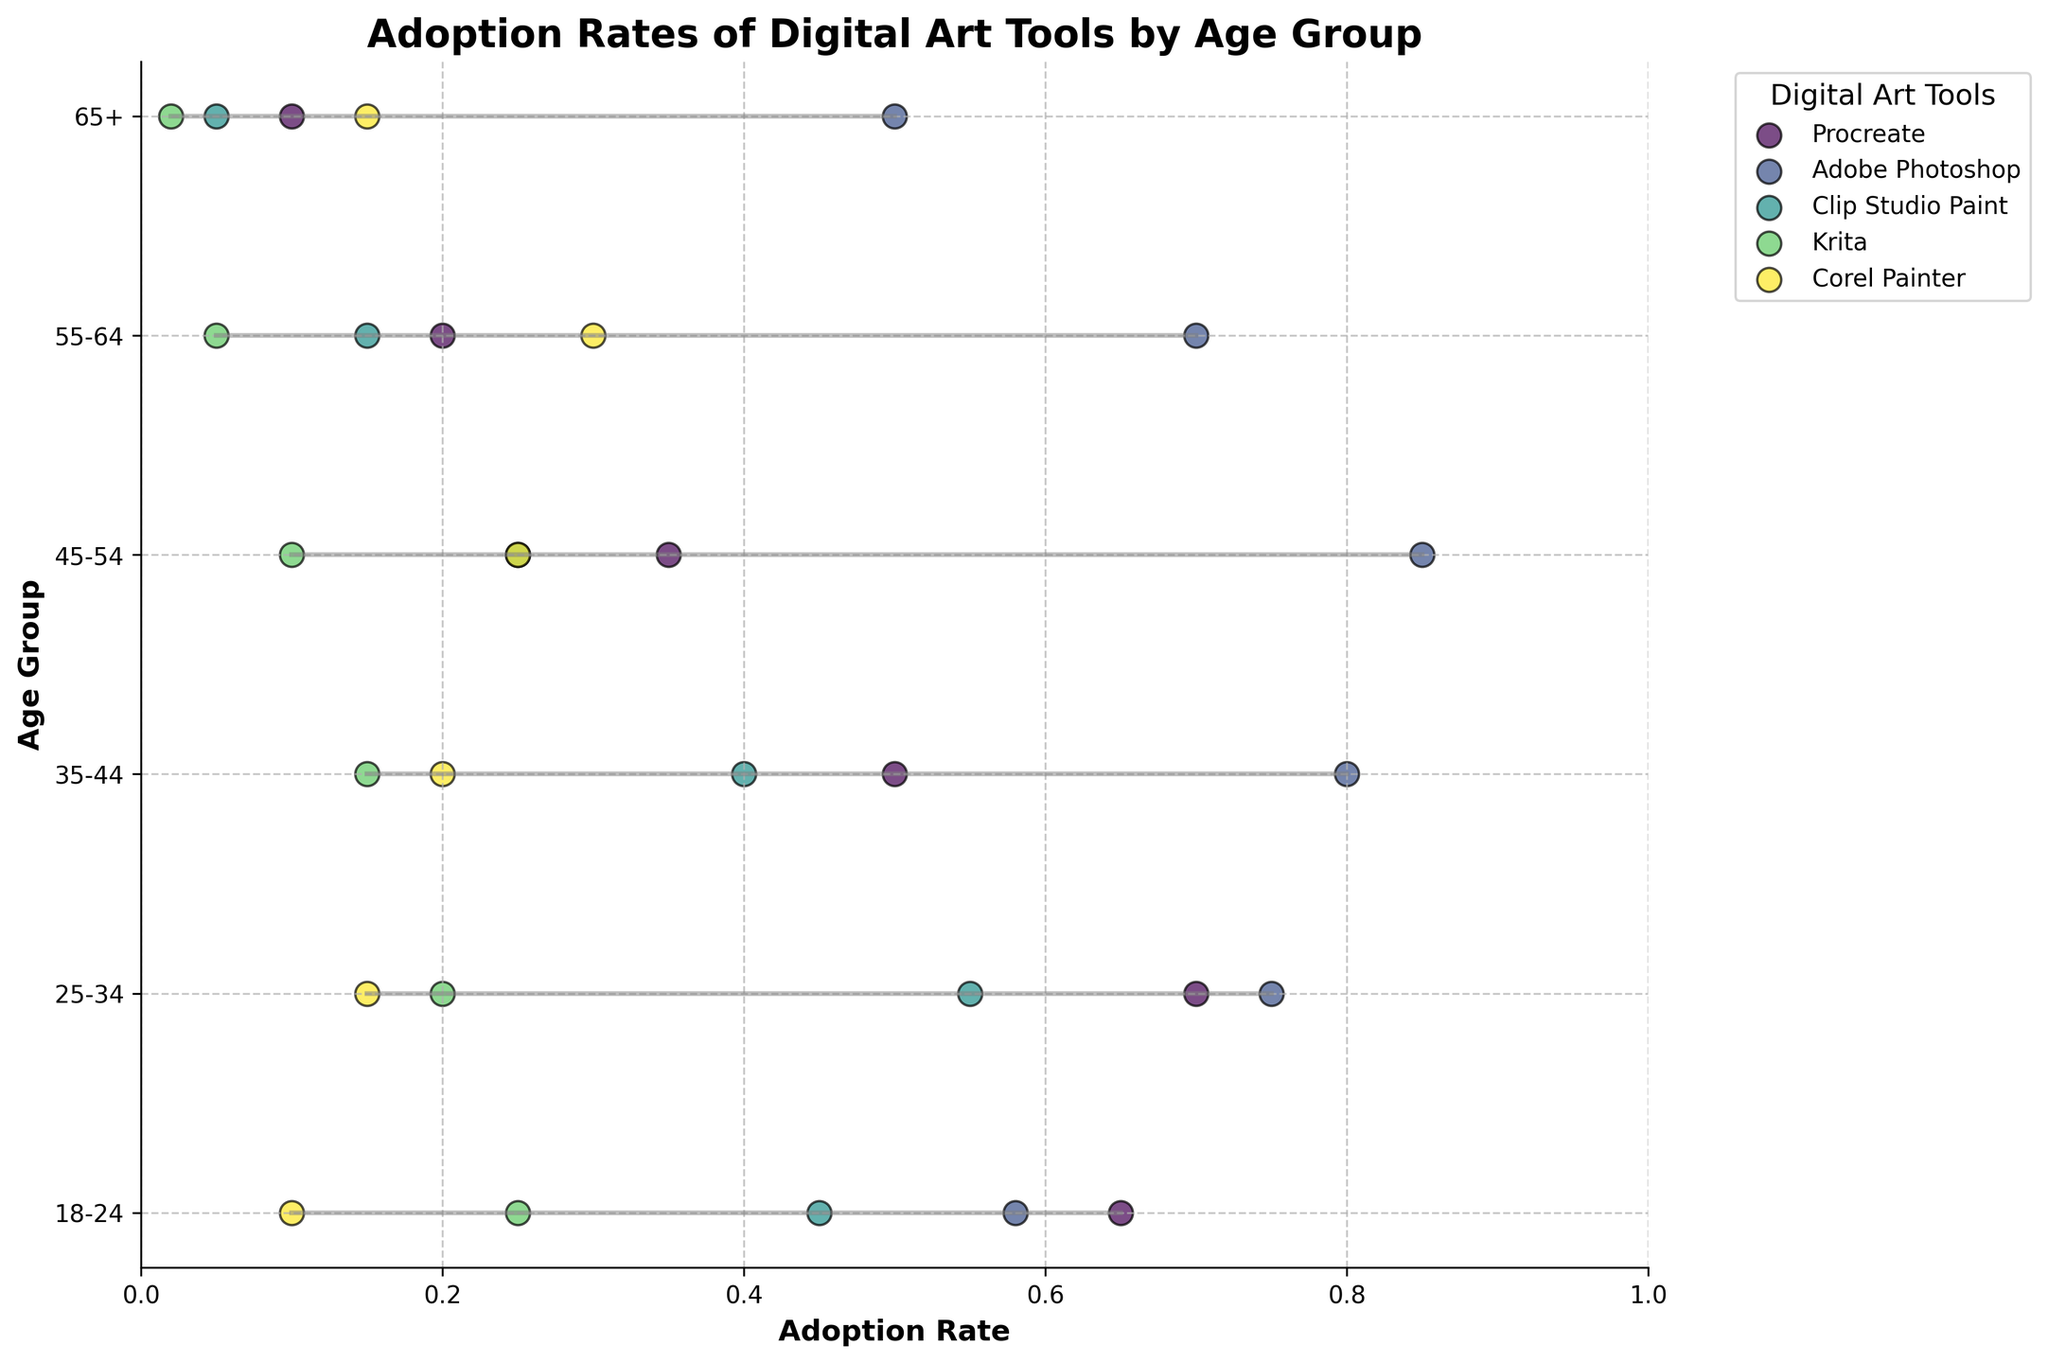Which digital art tool has the highest adoption rate among the 35-44 age group? First, find the data points for the 35-44 age group. Identify the tool with the highest value among this group. In the plot, Adobe Photoshop has the highest adoption rate with a value of 0.80.
Answer: Adobe Photoshop What's the title of the figure? Look for the main heading or title text at the top of the figure. It states "Adoption Rates of Digital Art Tools by Age Group."
Answer: Adoption Rates of Digital Art Tools by Age Group Which two age groups have the maximum range in adoption rates for any tool? Observe the ranged lines for each age group. The age groups with the longest lines on the plot signify the largest range. The 45-54 and 55-64 age groups show the largest range differences from approximately 0.70 to 0.85 and 0.05 to 0.70 respectively.
Answer: 45-54 and 55-64 What is the average adoption rate of Procreate across all age groups? List out the adoption rates of Procreate across all age groups: 0.65, 0.70, 0.50, 0.35, 0.20, 0.10. Sum these values and then divide by the number of age groups (6). Calculation: (0.65 + 0.70 + 0.50 + 0.35 + 0.20 + 0.10) / 6 = 0.4167.
Answer: 0.42 Between Adobe Photoshop and Procreate, which tool shows a greater variance in adoption rates across different age groups? Calculate the variance of adoption rates for both tools across age groups. Adobe Photoshop rates: 0.58, 0.75, 0.80, 0.85, 0.70, 0.50. Procreate rates: 0.65, 0.70, 0.50, 0.35, 0.20, 0.10. The variance for Adobe Photoshop is higher due to larger differences.
Answer: Adobe Photoshop For the age group 25-34, how does the adoption rate of Clip Studio Paint compare to Krita? Locate the adoption rates for 25-34 group for both tools. Clip Studio Paint is at 0.55, while Krita is at 0.20. 0.55 is greater than 0.20.
Answer: Clip Studio Paint is higher Which tool has the most consistent adoption rate across age groups? Look for the tool with the smallest range between its highest and lowest adoption rates. Adobe Photoshop shows more consistency within the high adoption rates and fewer fluctuations.
Answer: Adobe Photoshop What is the difference in adoption rates of Procreate between the youngest (18-24) and oldest (65+) age groups? Subtract the adoption rate of the oldest group from the adoption rate of the youngest group for Procreate. Calculation: 0.65 (18-24) - 0.10 (65+).
Answer: 0.55 